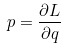Convert formula to latex. <formula><loc_0><loc_0><loc_500><loc_500>p = \frac { \partial L } { \partial q }</formula> 